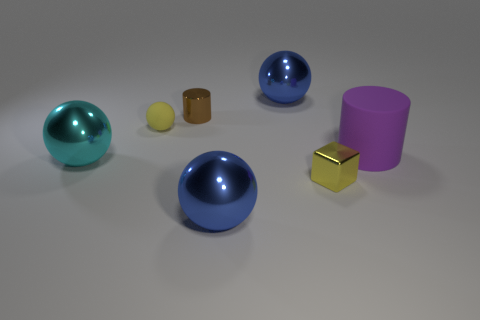Subtract 1 spheres. How many spheres are left? 3 Add 1 cyan metal balls. How many objects exist? 8 Subtract all blocks. How many objects are left? 6 Subtract 0 gray cylinders. How many objects are left? 7 Subtract all tiny purple rubber cylinders. Subtract all small objects. How many objects are left? 4 Add 5 cyan shiny things. How many cyan shiny things are left? 6 Add 5 tiny red metal cubes. How many tiny red metal cubes exist? 5 